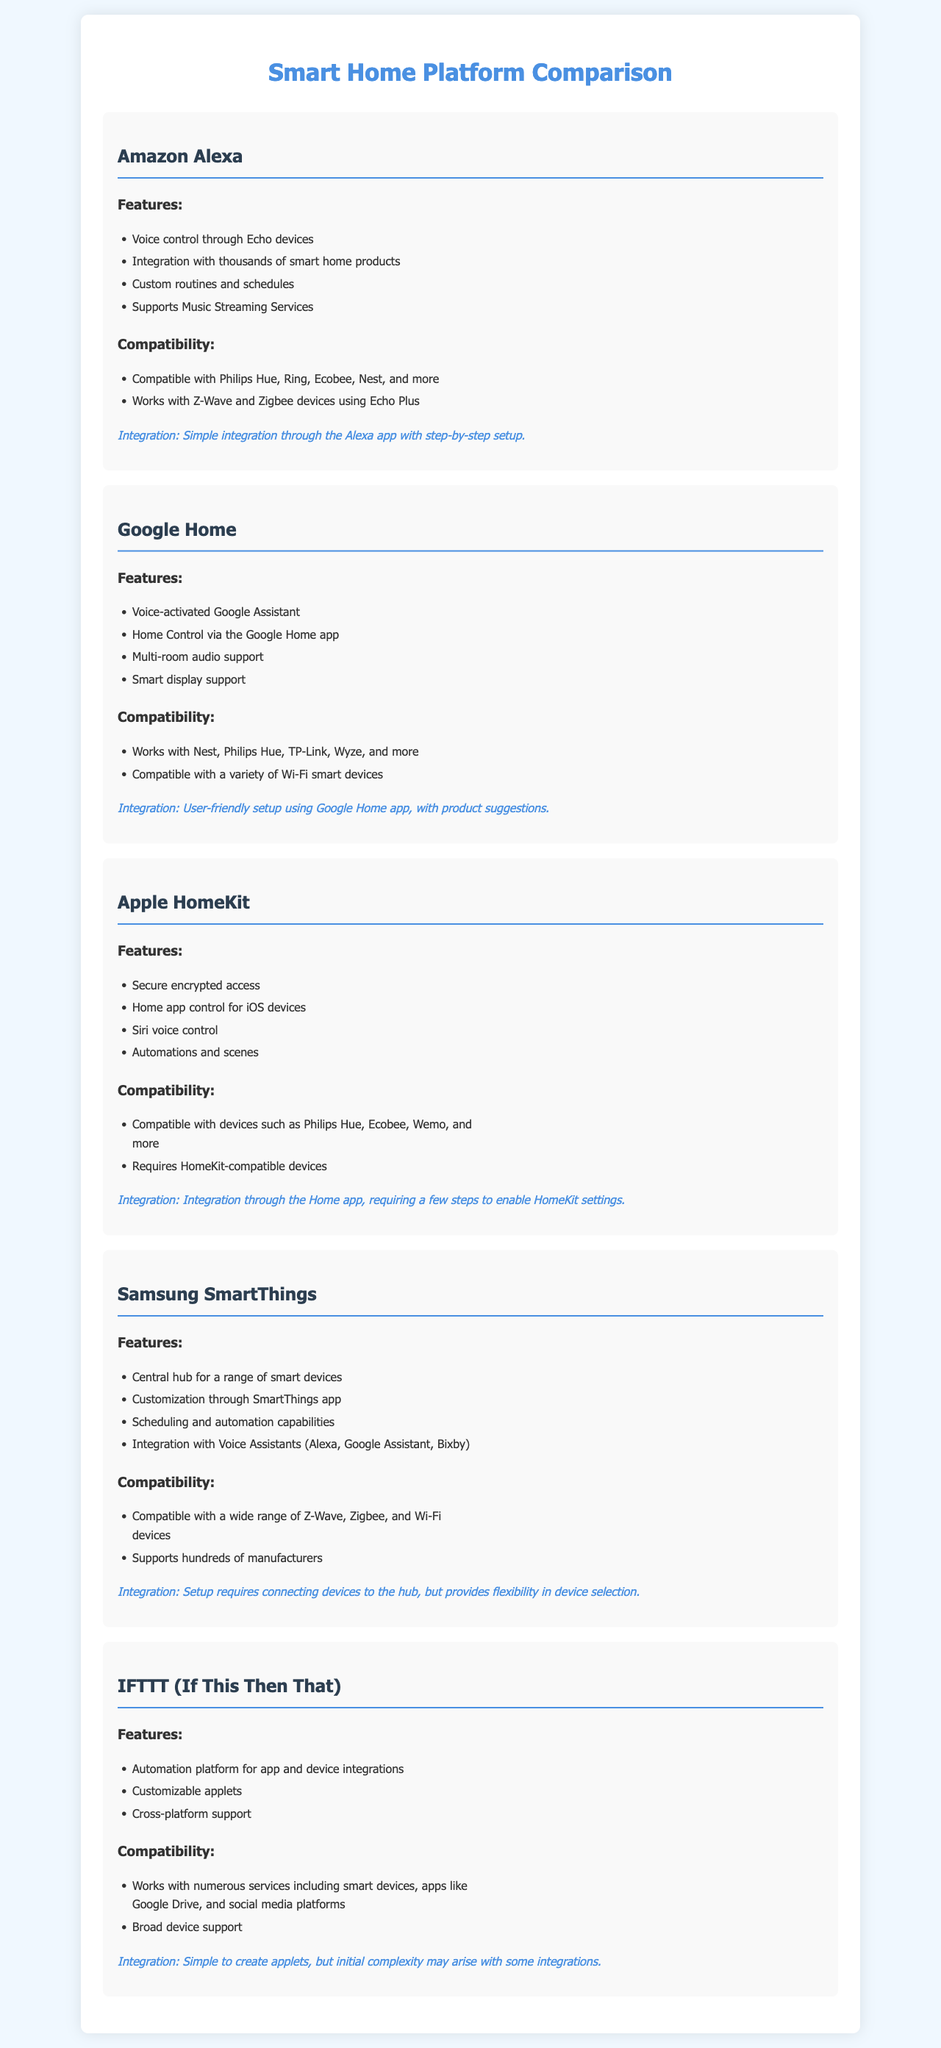What is the voice control feature of Amazon Alexa? The voice control feature of Amazon Alexa allows users to control their devices through Echo devices.
Answer: Voice control through Echo devices Which platform supports multi-room audio? Multi-room audio support is a feature mentioned for Google Home.
Answer: Multi-room audio support What is required for Apple HomeKit compatibility? Apple HomeKit requires HomeKit-compatible devices for its functionality.
Answer: HomeKit-compatible devices How does Samsung SmartThings allow customization? Samsung SmartThings enables customization through the SmartThings app.
Answer: SmartThings app Which integration method is highlighted for IFTTT? The integration method for IFTTT is creating customizable applets.
Answer: Customizable applets What types of devices does Samsung SmartThings support? Samsung SmartThings supports Z-Wave, Zigbee, and Wi-Fi devices.
Answer: Z-Wave, Zigbee, and Wi-Fi devices How is the integration process described for Amazon Alexa? The integration process for Amazon Alexa is described as simple through the Alexa app with step-by-step setup.
Answer: Simple integration through the Alexa app What does Google Home suggest to enhance setup? Google Home suggests product recommendations during setup to enhance user experience.
Answer: Product suggestions 